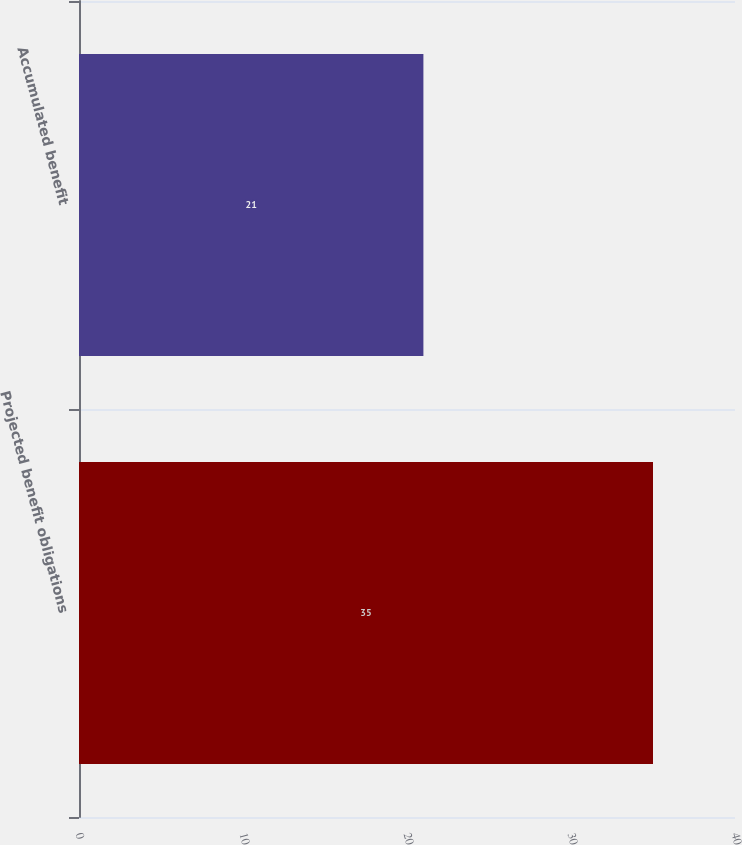<chart> <loc_0><loc_0><loc_500><loc_500><bar_chart><fcel>Projected benefit obligations<fcel>Accumulated benefit<nl><fcel>35<fcel>21<nl></chart> 